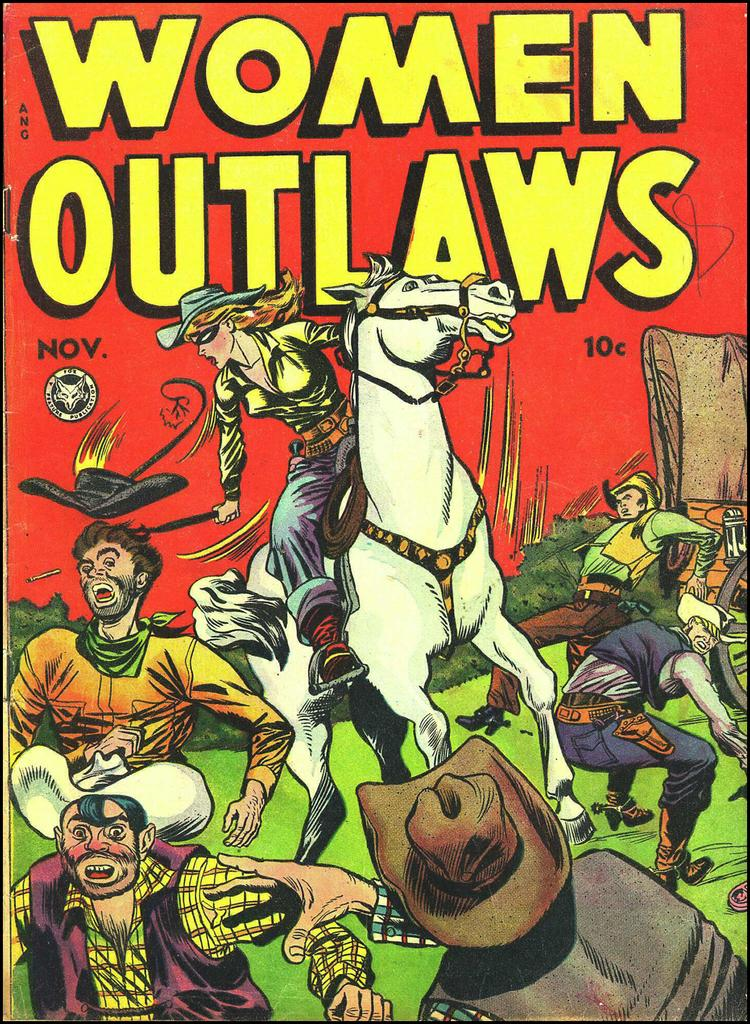<image>
Relay a brief, clear account of the picture shown. A comic book edition of Women Outlaws where a woman rides a white horse and is fighting cowboys. 